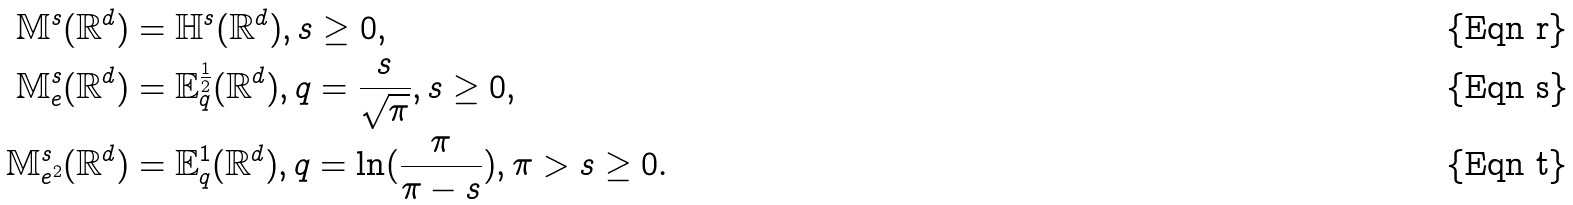<formula> <loc_0><loc_0><loc_500><loc_500>\mathbb { M } ^ { s } ( \mathbb { R } ^ { d } ) & = \mathbb { H } ^ { s } ( \mathbb { R } ^ { d } ) , s \geq 0 , \\ \mathbb { M } ^ { s } _ { e } ( \mathbb { R } ^ { d } ) & = \mathbb { E } ^ { \frac { 1 } { 2 } } _ { q } ( \mathbb { R } ^ { d } ) , q = \frac { s } { \sqrt { \pi } } , s \geq 0 , \\ \mathbb { M } ^ { s } _ { e ^ { 2 } } ( \mathbb { R } ^ { d } ) & = \mathbb { E } ^ { 1 } _ { q } ( \mathbb { R } ^ { d } ) , q = \ln ( \frac { \pi } { \pi - s } ) , \pi > s \geq 0 .</formula> 